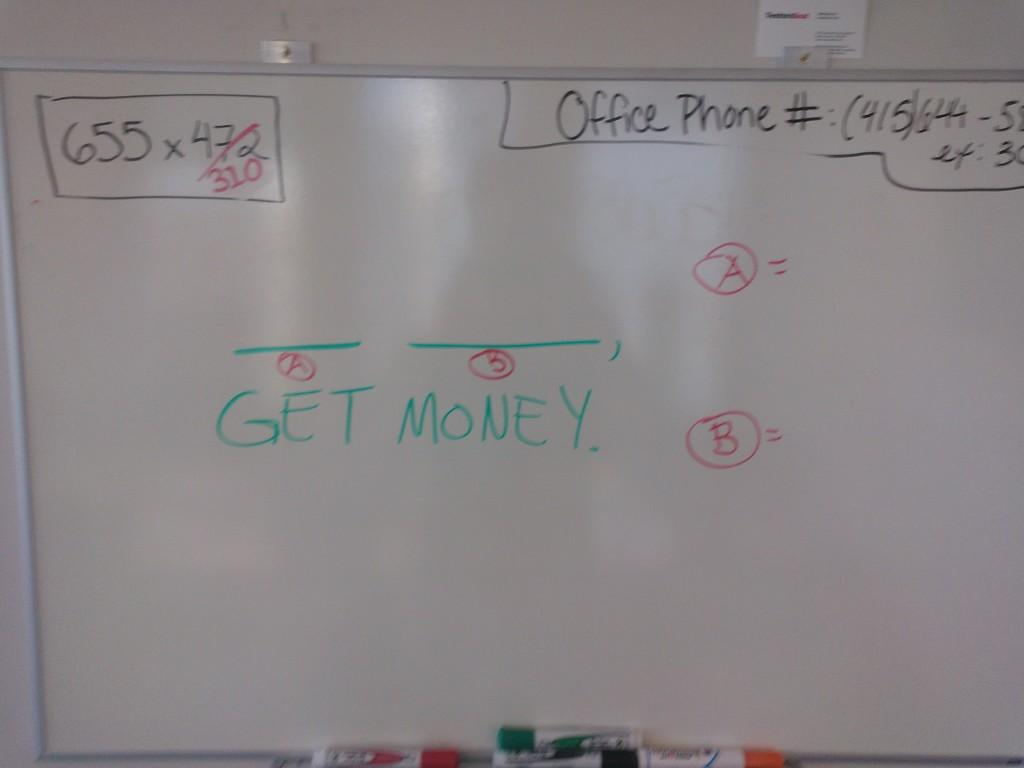<image>
Relay a brief, clear account of the picture shown. The clear message from this board is to GET MONEY. 